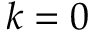<formula> <loc_0><loc_0><loc_500><loc_500>k = 0</formula> 